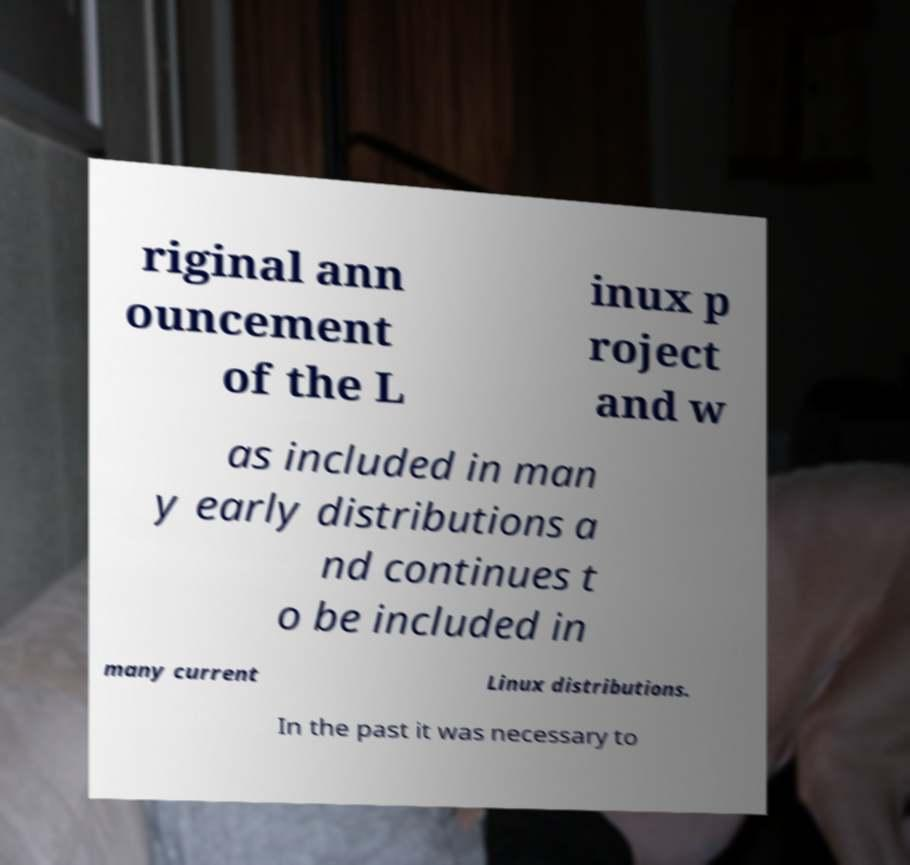Could you extract and type out the text from this image? riginal ann ouncement of the L inux p roject and w as included in man y early distributions a nd continues t o be included in many current Linux distributions. In the past it was necessary to 